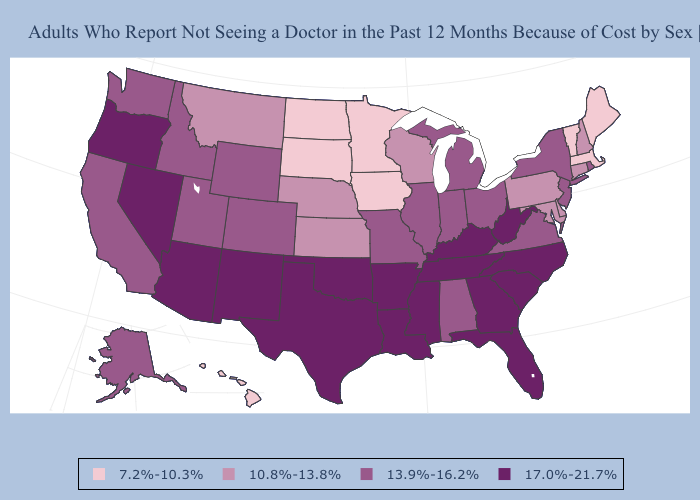Does Iowa have the lowest value in the USA?
Answer briefly. Yes. Does Montana have the highest value in the West?
Be succinct. No. What is the highest value in states that border Kansas?
Concise answer only. 17.0%-21.7%. Does Michigan have a lower value than North Carolina?
Keep it brief. Yes. Among the states that border Michigan , does Wisconsin have the highest value?
Concise answer only. No. Is the legend a continuous bar?
Keep it brief. No. Among the states that border Washington , which have the highest value?
Short answer required. Oregon. Which states have the highest value in the USA?
Quick response, please. Arizona, Arkansas, Florida, Georgia, Kentucky, Louisiana, Mississippi, Nevada, New Mexico, North Carolina, Oklahoma, Oregon, South Carolina, Tennessee, Texas, West Virginia. Does South Dakota have the lowest value in the USA?
Quick response, please. Yes. Among the states that border Tennessee , which have the highest value?
Answer briefly. Arkansas, Georgia, Kentucky, Mississippi, North Carolina. What is the value of Mississippi?
Concise answer only. 17.0%-21.7%. Does Hawaii have a lower value than Michigan?
Be succinct. Yes. Does Oregon have the highest value in the West?
Answer briefly. Yes. What is the lowest value in states that border Virginia?
Keep it brief. 10.8%-13.8%. How many symbols are there in the legend?
Answer briefly. 4. 